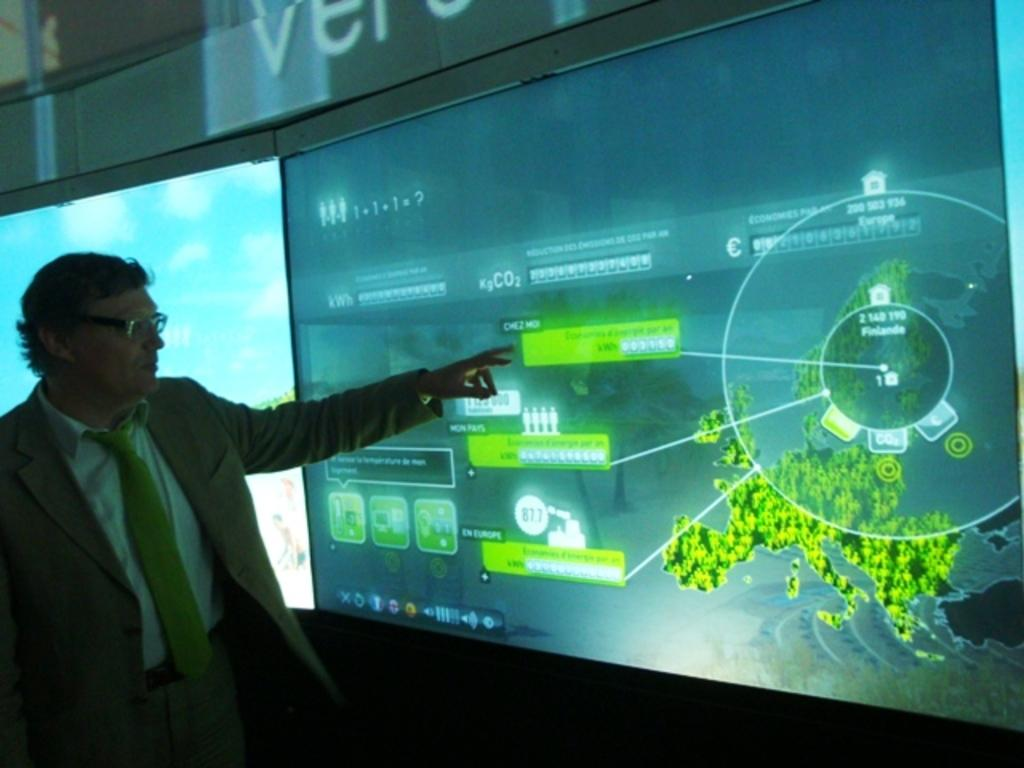<image>
Relay a brief, clear account of the picture shown. A sign that starts with V hangs over a complicated computer display. 